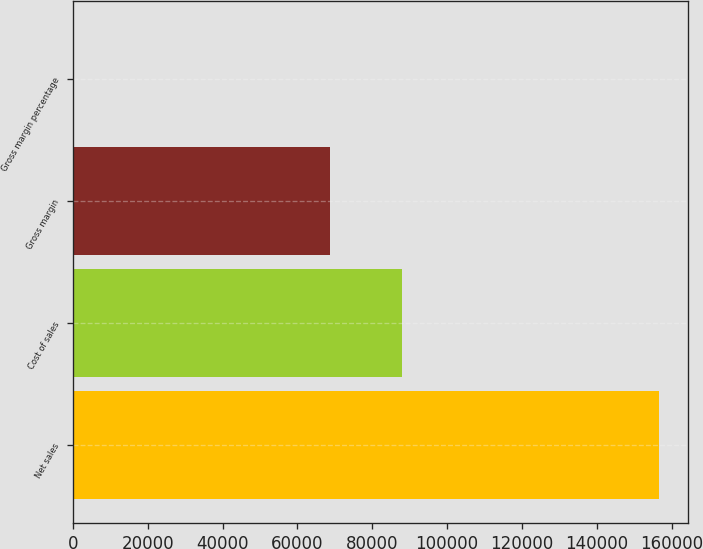Convert chart. <chart><loc_0><loc_0><loc_500><loc_500><bar_chart><fcel>Net sales<fcel>Cost of sales<fcel>Gross margin<fcel>Gross margin percentage<nl><fcel>156508<fcel>87846<fcel>68662<fcel>43.9<nl></chart> 